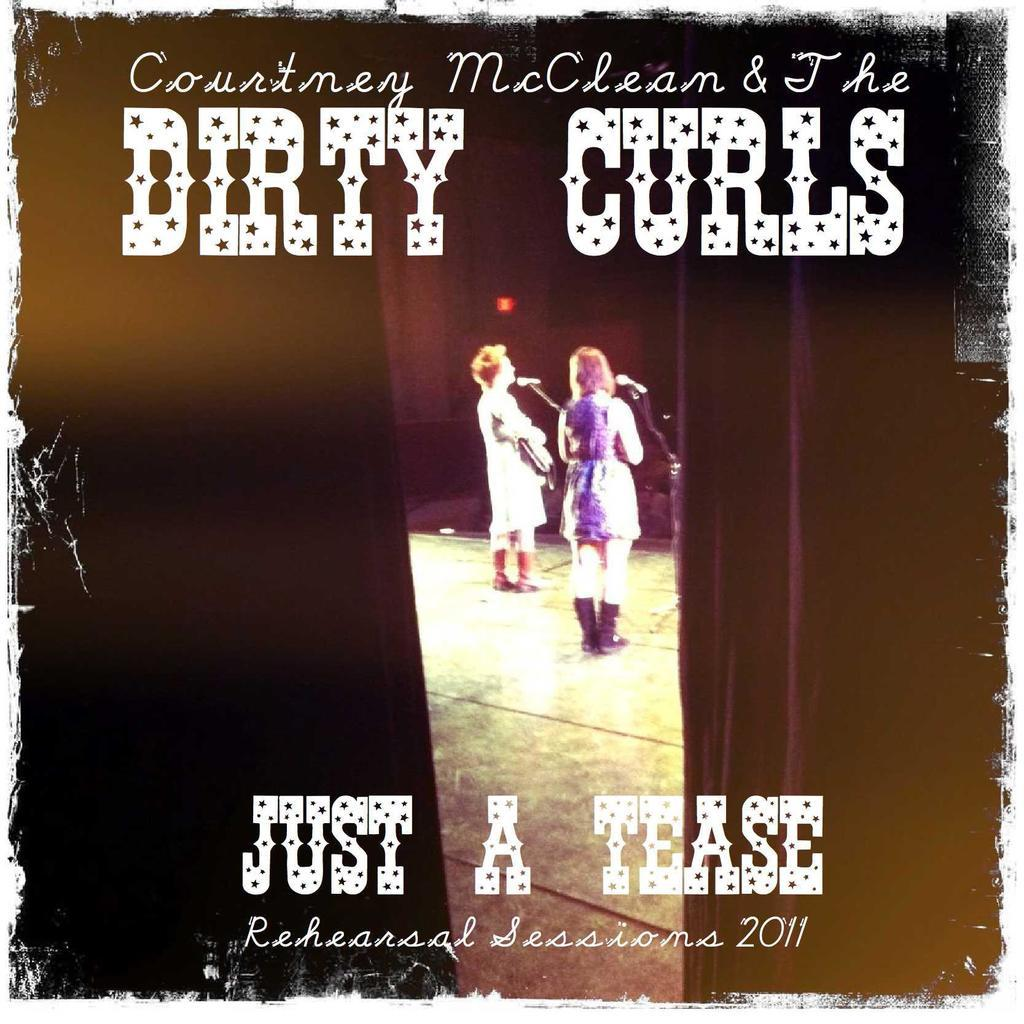<image>
Summarize the visual content of the image. An album is titled Just a Tease and shows to woman on the cover. 